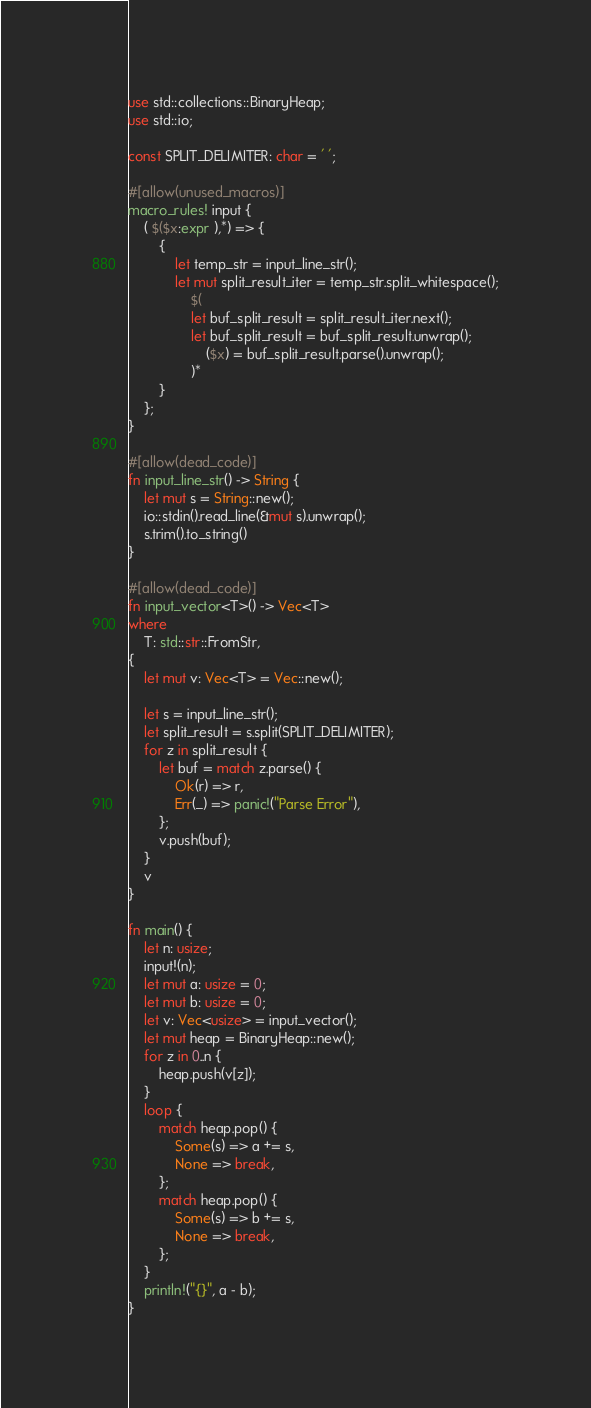<code> <loc_0><loc_0><loc_500><loc_500><_Rust_>use std::collections::BinaryHeap;
use std::io;

const SPLIT_DELIMITER: char = ' ';

#[allow(unused_macros)]
macro_rules! input {
    ( $($x:expr ),*) => {
        {
            let temp_str = input_line_str();
            let mut split_result_iter = temp_str.split_whitespace();
                $(
                let buf_split_result = split_result_iter.next();
                let buf_split_result = buf_split_result.unwrap();
                    ($x) = buf_split_result.parse().unwrap();
                )*
        }
    };
}

#[allow(dead_code)]
fn input_line_str() -> String {
    let mut s = String::new();
    io::stdin().read_line(&mut s).unwrap();
    s.trim().to_string()
}

#[allow(dead_code)]
fn input_vector<T>() -> Vec<T>
where
    T: std::str::FromStr,
{
    let mut v: Vec<T> = Vec::new();

    let s = input_line_str();
    let split_result = s.split(SPLIT_DELIMITER);
    for z in split_result {
        let buf = match z.parse() {
            Ok(r) => r,
            Err(_) => panic!("Parse Error"),
        };
        v.push(buf);
    }
    v
}

fn main() {
    let n: usize;
    input!(n);
    let mut a: usize = 0;
    let mut b: usize = 0;
    let v: Vec<usize> = input_vector();
    let mut heap = BinaryHeap::new();
    for z in 0..n {
        heap.push(v[z]);
    }
    loop {
        match heap.pop() {
            Some(s) => a += s,
            None => break,
        };
        match heap.pop() {
            Some(s) => b += s,
            None => break,
        };
    }
    println!("{}", a - b);
}</code> 